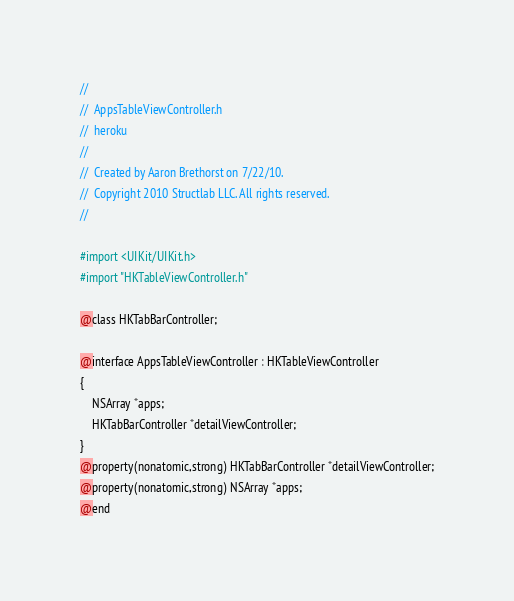Convert code to text. <code><loc_0><loc_0><loc_500><loc_500><_C_>//
//  AppsTableViewController.h
//  heroku
//
//  Created by Aaron Brethorst on 7/22/10.
//  Copyright 2010 Structlab LLC. All rights reserved.
//

#import <UIKit/UIKit.h>
#import "HKTableViewController.h"

@class HKTabBarController;

@interface AppsTableViewController : HKTableViewController
{
	NSArray *apps;
	HKTabBarController *detailViewController;
}
@property(nonatomic,strong) HKTabBarController *detailViewController;
@property(nonatomic,strong) NSArray *apps;
@end
</code> 